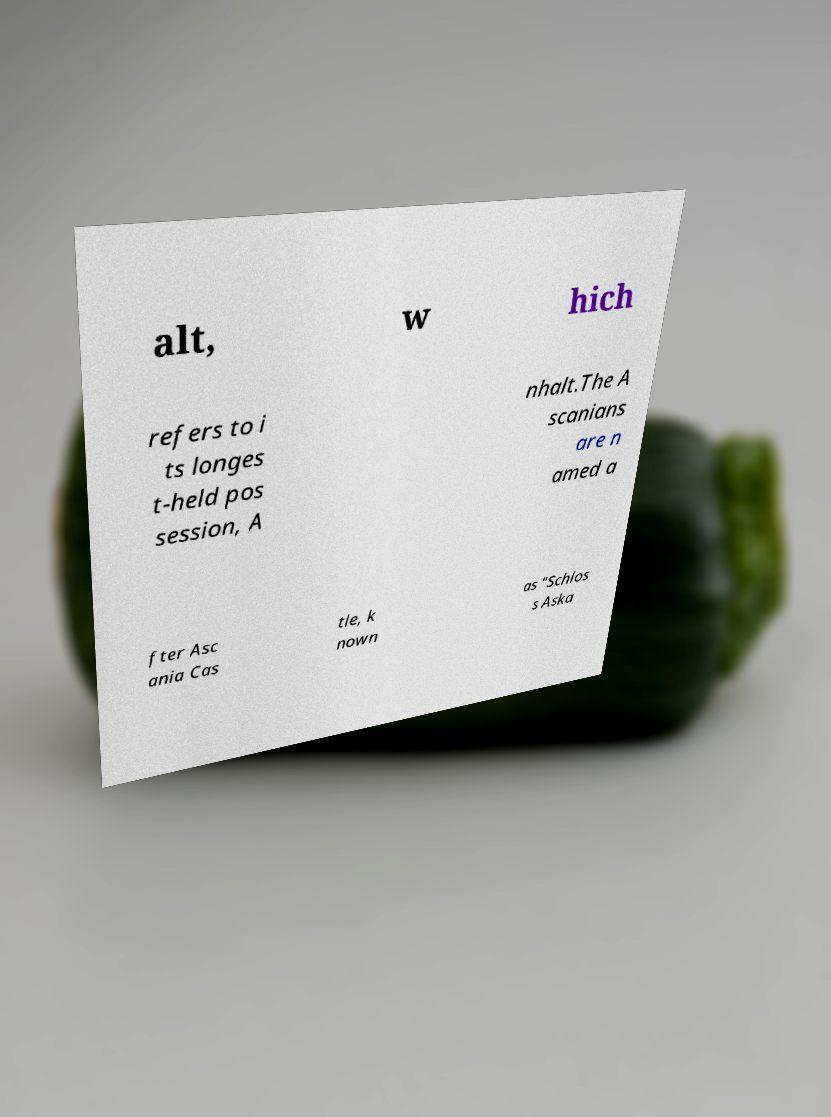Can you read and provide the text displayed in the image?This photo seems to have some interesting text. Can you extract and type it out for me? alt, w hich refers to i ts longes t-held pos session, A nhalt.The A scanians are n amed a fter Asc ania Cas tle, k nown as "Schlos s Aska 